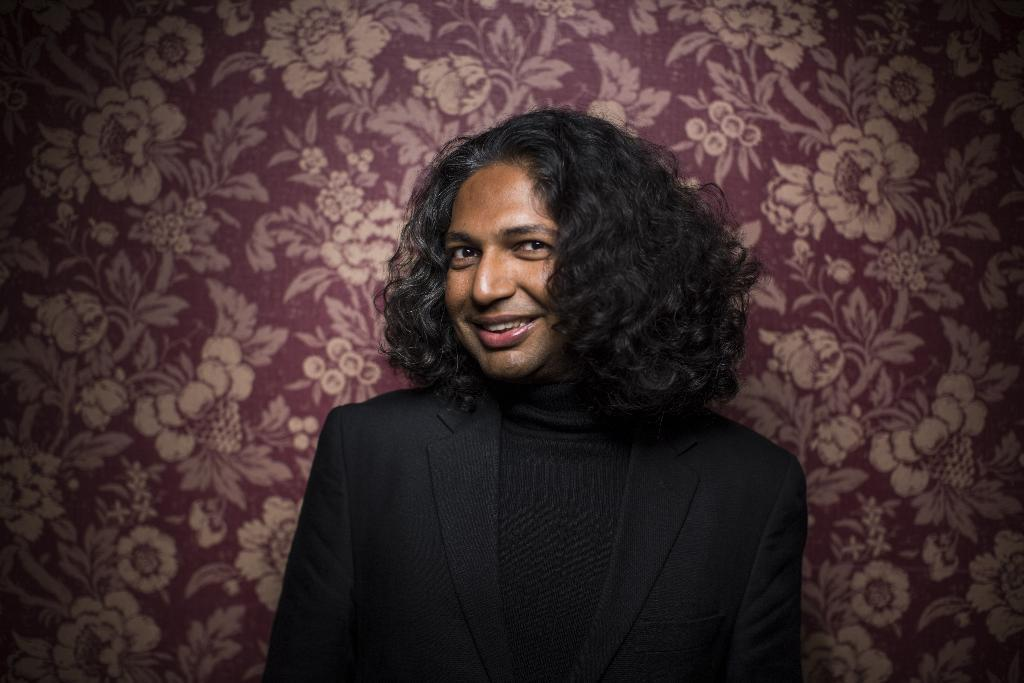What is the person in the image doing? The person is standing in the image. What is the person wearing? The person is wearing a black dress. What expression does the person have? The person is smiling. What can be seen on the wall in the image? There is a wall with designs in the image. What type of designs are on the wall? The designs on the wall include flowers. How many chickens are sitting on the person's shoulder in the image? There are no chickens present in the image. What type of team is the person a part of in the image? There is no indication of a team in the image. 